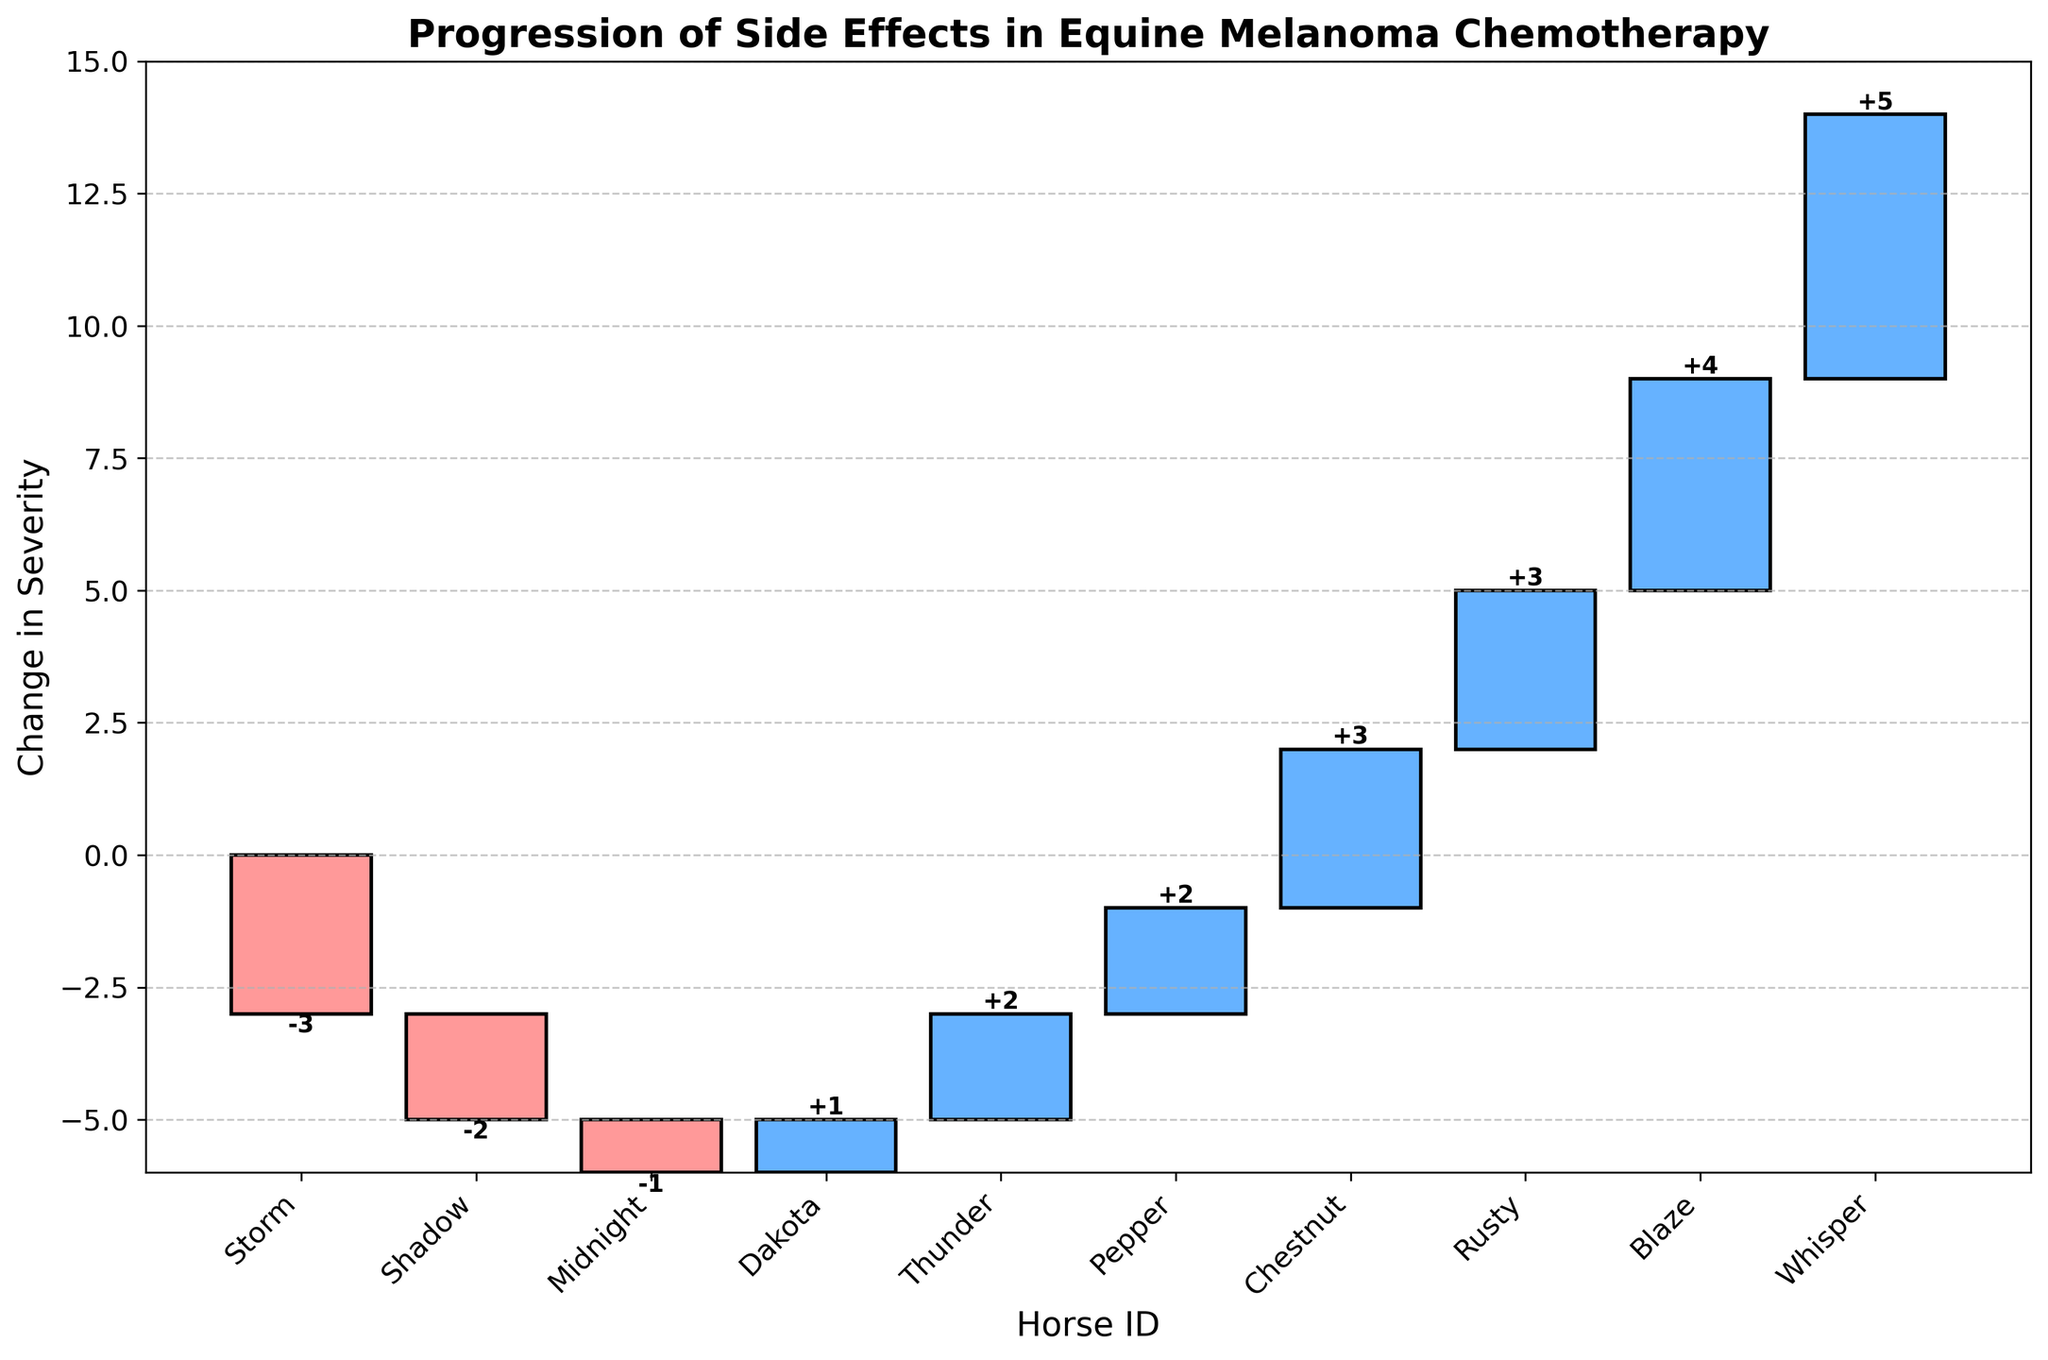Which horse experienced the largest increase in the severity of side effects? Whisper experienced the highest increase in side effects with a change in severity of +5. This can be seen from the tallest blue bar in the figure.
Answer: Whisper Which horse had the largest reduction in severity of side effects? Storm had the largest reduction with a change in severity of -3. This can be seen from the tallest red bar in the figure.
Answer: Storm How many horses had an increase in side effect severity? By counting the blue bars which represent an increase, there are 7 horses with an increase in severity of side effects.
Answer: 7 How many horses experienced a decrease in side effect severity? By counting the red bars, which indicate a decrease, there are 3 horses with a decrease in side effect severity.
Answer: 3 What's the total cumulative change in severity across all horses? The cumulative change in severity is the sum of all changes (+2 - 3 + 4 + 5 + 3 - 1 + 2 + 1 - 2 + 3), which equals +14.
Answer: +14 Which horse had a severity change closest to zero? Midnight, with a change in severity of -1, is closest to zero. This is visible by comparing the absolute values of all side effect changes.
Answer: Midnight Compare the severity change in side effects between Thunder and Dakota. Which had a larger increase? Thunder had an increase of +2, while Dakota had an increase of +1. Therefore, Thunder had a larger increase.
Answer: Thunder What is the average change in severity for the horses that experienced an increase in side effects? Sum the increases (+2 + 4 + 5 + 3 + 2 + 1 + 3) which equals 20, and then divide by the number of horses (7). The average is 20/7 = approximately 2.86.
Answer: 2.86 If we consider only the horses with a reduction in side effect severity, what is the average reduction? Sum the reductions (-3 -1 -2) which equals -6, and then divide by the number of horses (3). The average reduction is -6/3 = -2.
Answer: -2 Identify the horse with the smallest positive increase in side effect severity. Dakota had the smallest positive increase with a change of +1, which can be identified by the shortest blue bar.
Answer: Dakota 